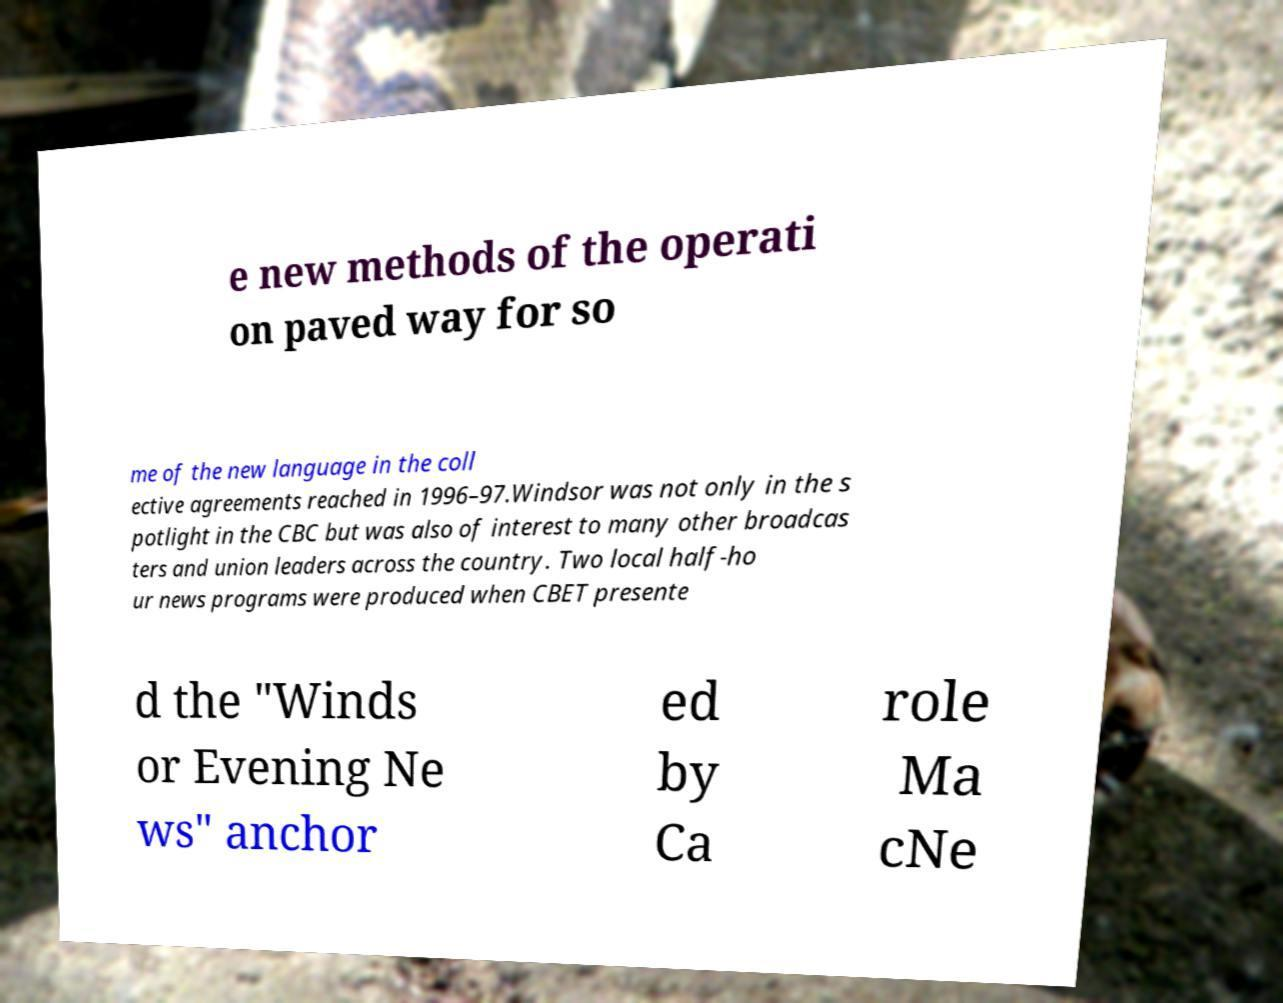For documentation purposes, I need the text within this image transcribed. Could you provide that? e new methods of the operati on paved way for so me of the new language in the coll ective agreements reached in 1996–97.Windsor was not only in the s potlight in the CBC but was also of interest to many other broadcas ters and union leaders across the country. Two local half-ho ur news programs were produced when CBET presente d the "Winds or Evening Ne ws" anchor ed by Ca role Ma cNe 